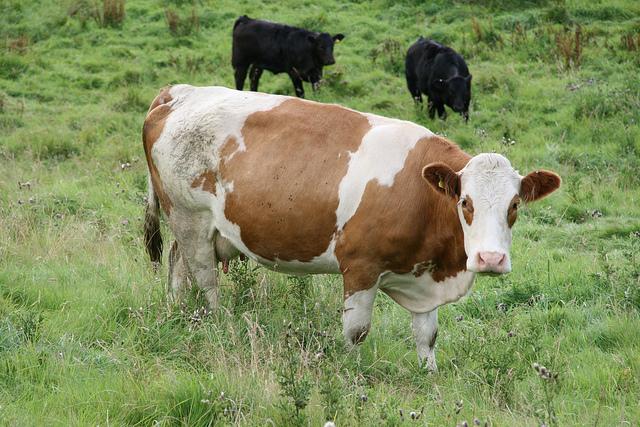What is this cow looking at?
Answer briefly. Camera. Is the cow wild of farm?
Give a very brief answer. Farm. Do these animals all look alike?
Answer briefly. No. Are any of the cows facing the camera?
Write a very short answer. Yes. 